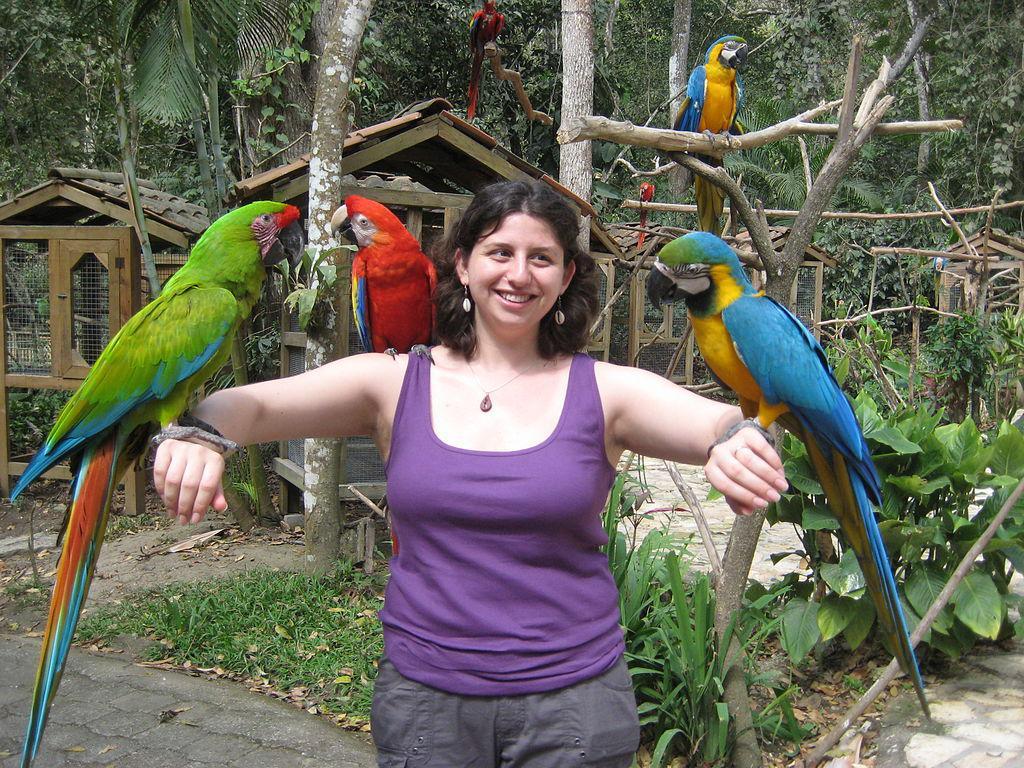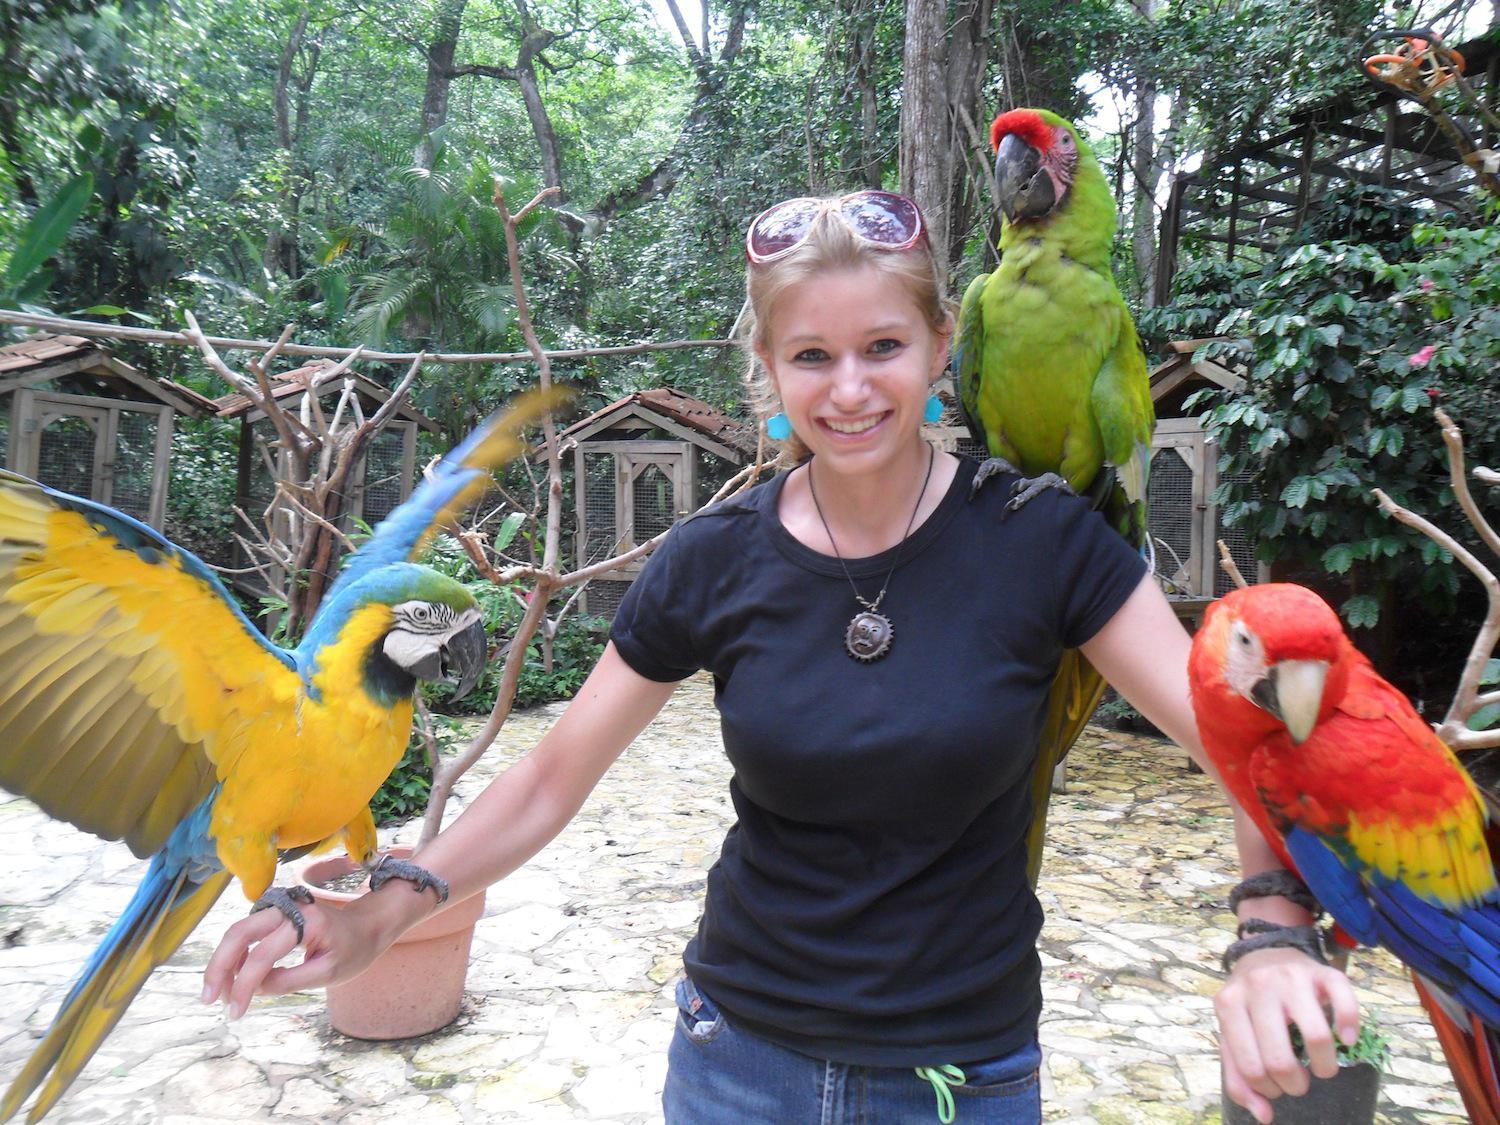The first image is the image on the left, the second image is the image on the right. Considering the images on both sides, is "On both pictures, parrots can be seen perched on a human, one on each arm and one on a shoulder." valid? Answer yes or no. Yes. The first image is the image on the left, the second image is the image on the right. Analyze the images presented: Is the assertion "There are three birds sitting on a person,  one on each arm and one on their shoulder." valid? Answer yes or no. Yes. 